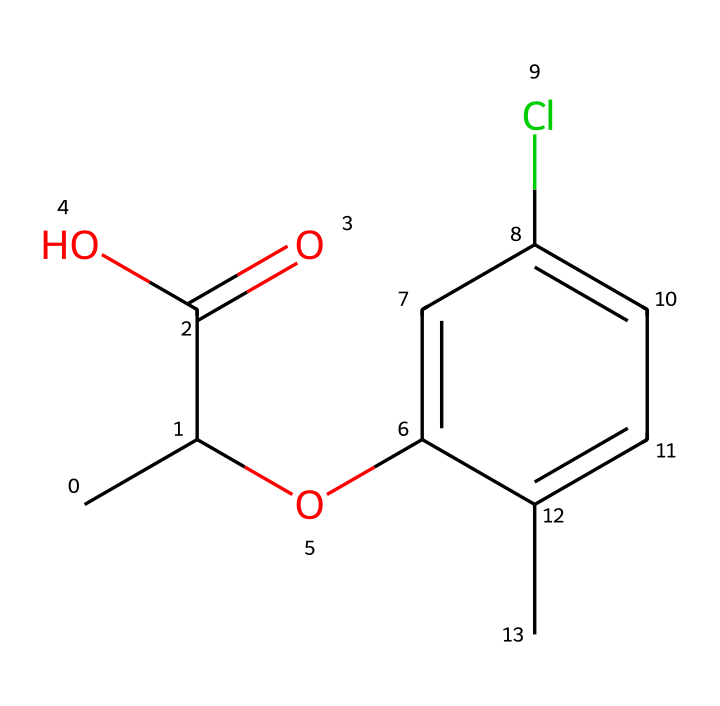What is the molecular formula of mecoprop? To determine the molecular formula from the SMILES, we identify the constituents. The SMILES indicates that there are 10 carbon (C) atoms, 11 hydrogen (H) atoms, 2 oxygen (O) atoms, and 1 chlorine (Cl) atom. Thus, the molecular formula can be constructed as C10H11ClO2.
Answer: C10H11ClO2 How many rings are present in the molecular structure? Analyzing the SMILES representation, the portion "c1cc(Cl)ccc1" indicates the presence of a cyclical structure, specifically a benzene ring. Since there is only one such indicator in the given chemical structure, we conclude there is one ring present.
Answer: 1 What type of herbicide is mecoprop classified as? Mecoprop is a selective herbicide, which means it is designed to target specific types of plants, particularly broadleaf weeds, while minimizing damage to grasses. Based on its structure and application, it is classified as a phenoxy herbicide.
Answer: phenoxy What functional groups are present in mecoprop? The SMILES shows two main functional groups: one is a carboxylic acid group (-COOH) inferred from 'C(=O)O', and the second is an ether linkage indicated by 'Oc'. Therefore, the main functional groups are the carboxylic acid and the ether.
Answer: carboxylic acid and ether What is the significance of the chlorine atom in mecoprop? The chlorine atom in the structure plays a critical role in the herbicide's effectiveness and selectivity. It can influence the molecular interactions, making mecoprop more effective at disrupting the growth of certain plants, particularly broadleaf types. This property is related to the herbicidal activity and selectivity of the compound.
Answer: herbicidal activity and selectivity What is the total number of atoms in mecoprop? To find the total number of atoms, we count the individual atoms based on the molecular formula derived earlier. The molecule contains 10 carbons, 11 hydrogens, 1 chlorine, and 2 oxygens. Therefore, the total atomic count is 10 + 11 + 1 + 2 = 24 atoms.
Answer: 24 